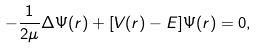<formula> <loc_0><loc_0><loc_500><loc_500>- \frac { 1 } { 2 \mu } \Delta \Psi ( { r } ) + [ V ( { r } ) - E ] \Psi ( { r } ) = 0 ,</formula> 